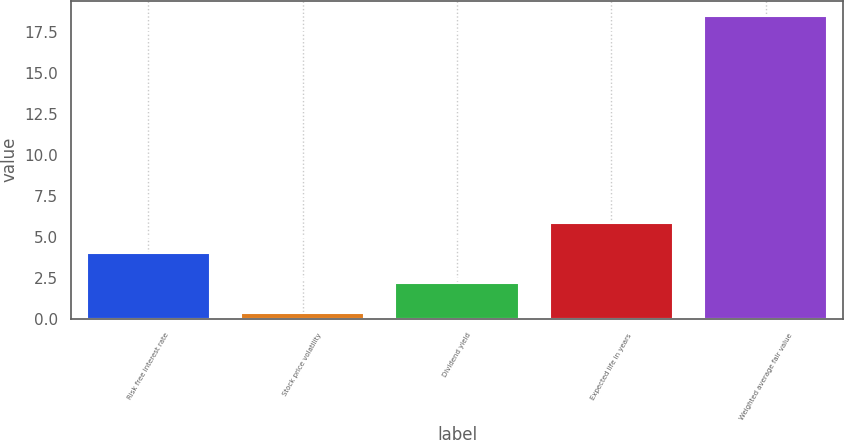Convert chart. <chart><loc_0><loc_0><loc_500><loc_500><bar_chart><fcel>Risk free interest rate<fcel>Stock price volatility<fcel>Dividend yield<fcel>Expected life in years<fcel>Weighted average fair value<nl><fcel>4.01<fcel>0.39<fcel>2.2<fcel>5.82<fcel>18.47<nl></chart> 